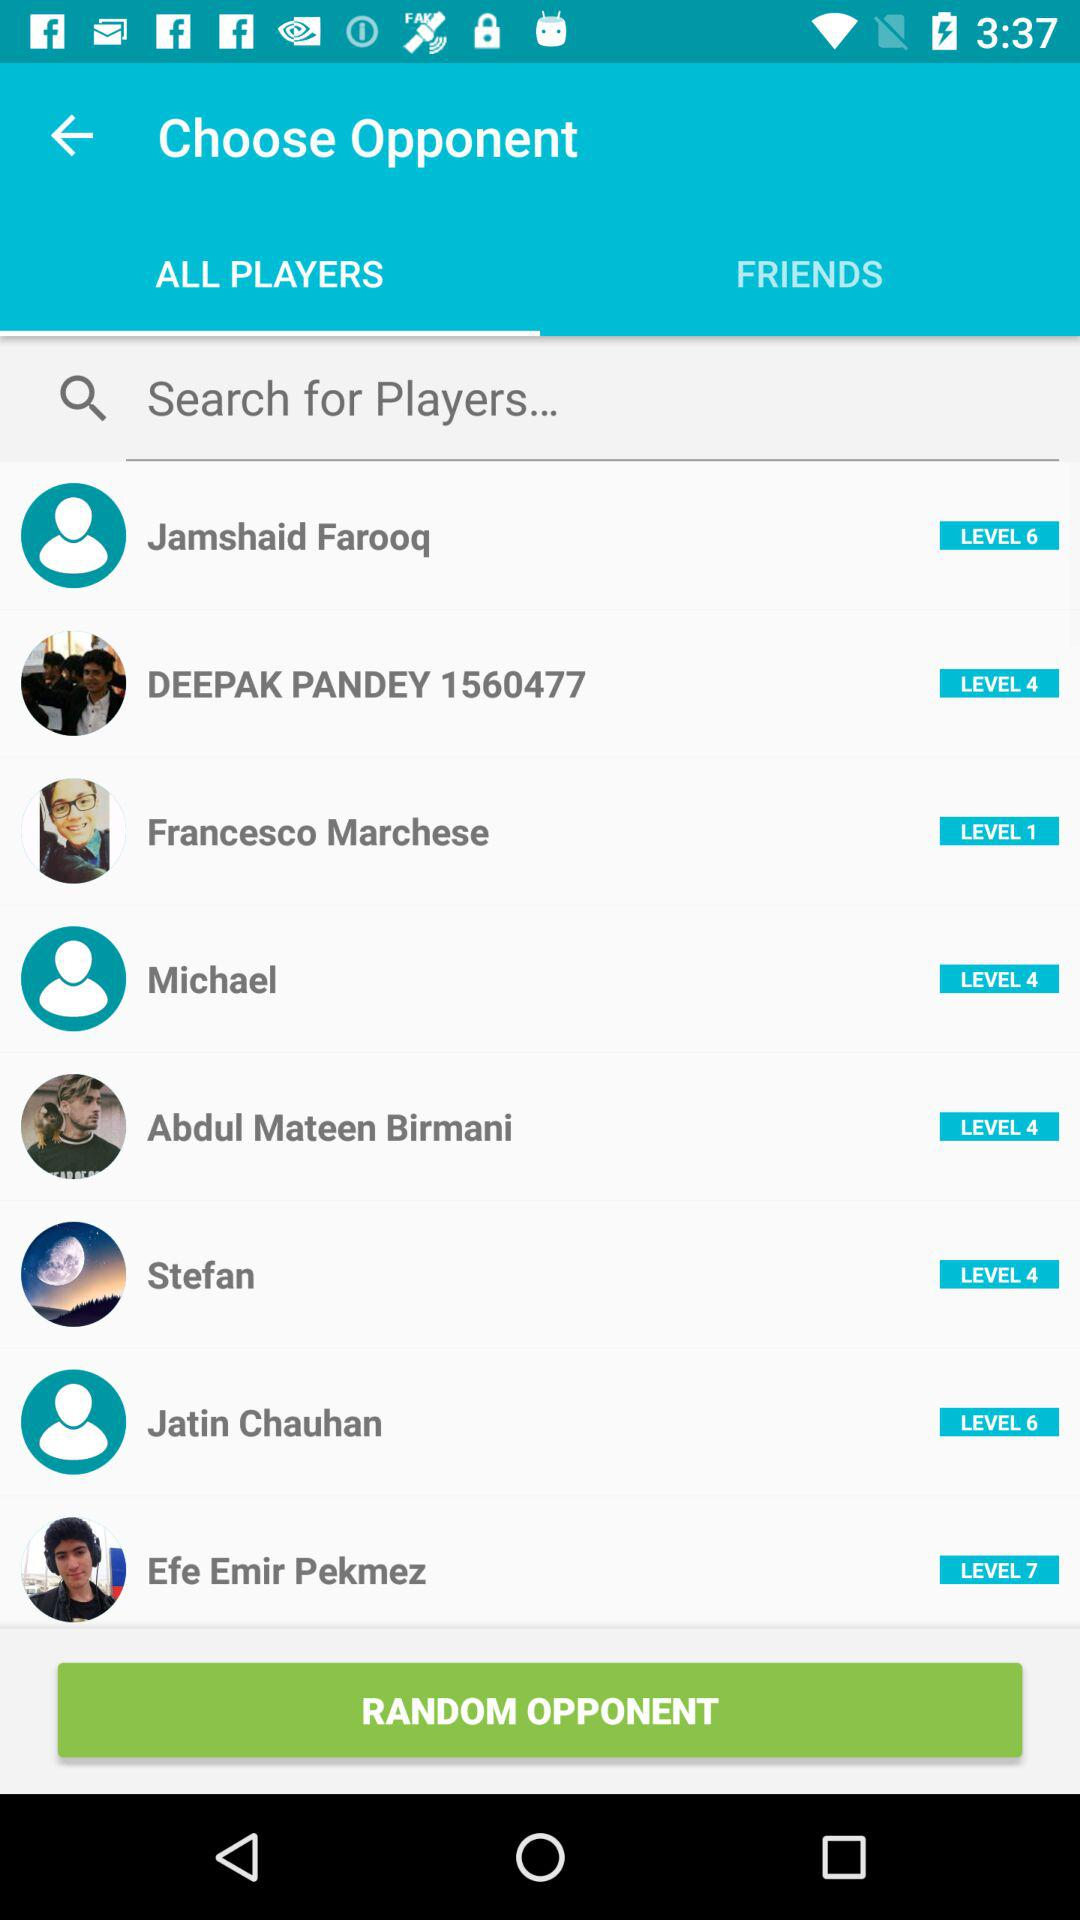What are the available players in the list? The available players in the list are Jamshaid Farooq, Deepak Pandey, Francesco Marchese, Michael, Abdul Mateen Birmani, Stefan, Jatin Chauhan and Efe Emir Pekmez. 